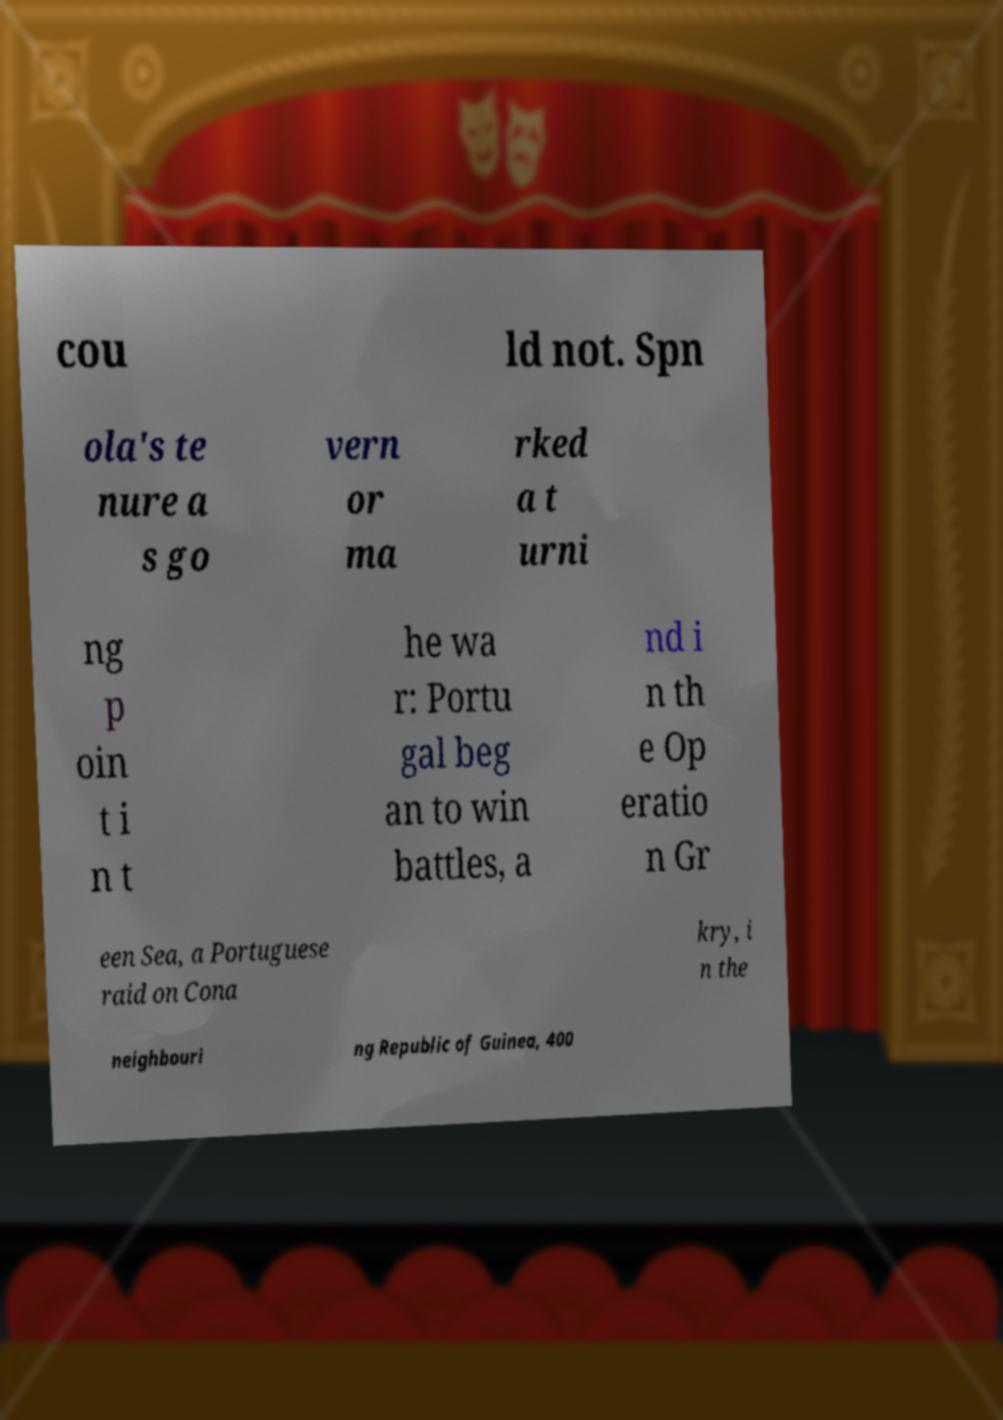Please identify and transcribe the text found in this image. cou ld not. Spn ola's te nure a s go vern or ma rked a t urni ng p oin t i n t he wa r: Portu gal beg an to win battles, a nd i n th e Op eratio n Gr een Sea, a Portuguese raid on Cona kry, i n the neighbouri ng Republic of Guinea, 400 